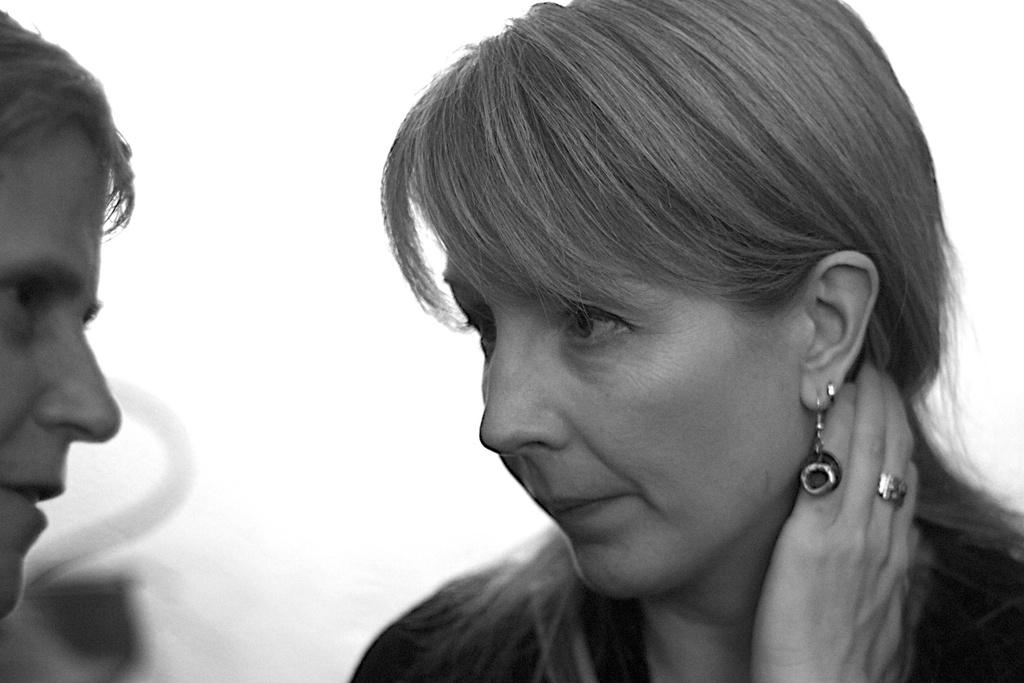What is the color scheme of the image? The image is black and white. What people can be seen in the image? There is a man and a woman in the image. What type of creature is the man holding in the image? There is no creature present in the image; it only features a man and a woman. What order is the man giving to the woman in the image? There is no indication of any orders being given in the image, as it only shows a man and a woman. 